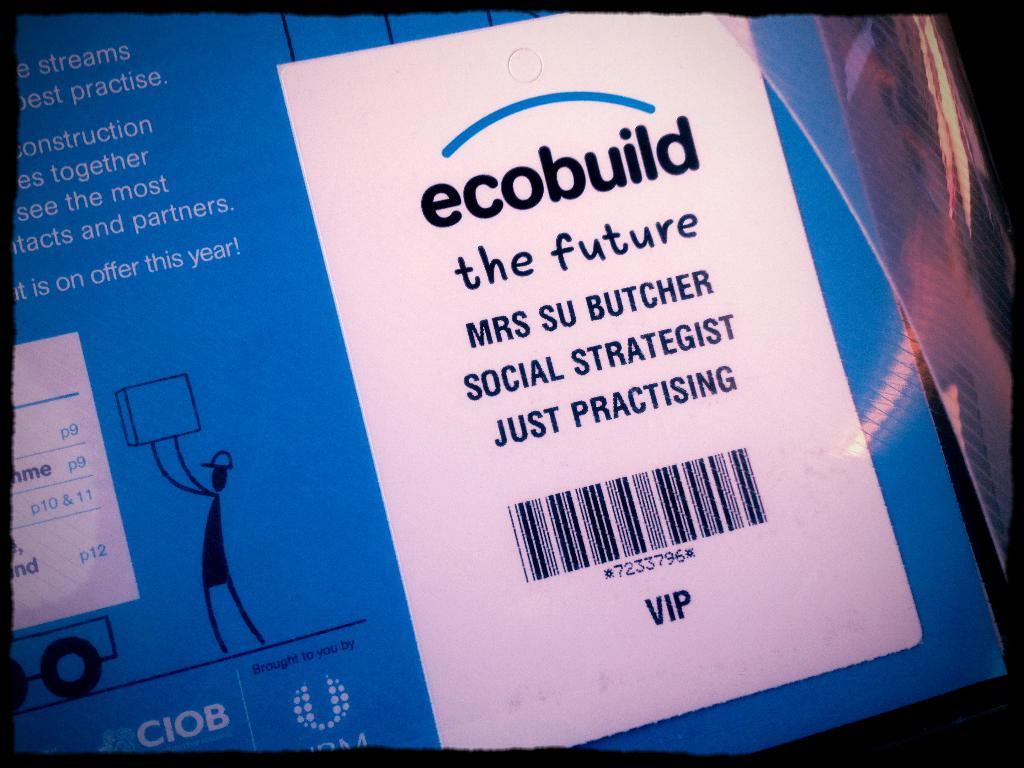Provide a one-sentence caption for the provided image. A label on a product labeled ecobuild and has the name Mrs. Su Butcher on it. 